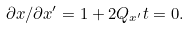<formula> <loc_0><loc_0><loc_500><loc_500>\partial x / \partial x ^ { \prime } = 1 + 2 Q _ { x ^ { \prime } } t = 0 .</formula> 